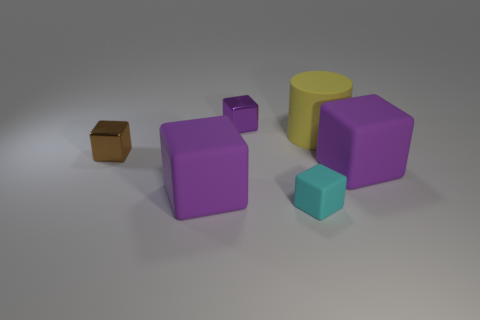What is the material of the large object that is to the left of the tiny matte thing in front of the rubber cylinder?
Give a very brief answer. Rubber. Is the number of tiny purple blocks that are in front of the big yellow rubber thing less than the number of small brown shiny balls?
Provide a short and direct response. No. There is a purple metallic object on the right side of the tiny brown shiny block; what shape is it?
Make the answer very short. Cube. There is a cyan block; does it have the same size as the cube to the right of the rubber cylinder?
Offer a terse response. No. Is there a green sphere that has the same material as the large yellow cylinder?
Offer a very short reply. No. What number of cylinders are either big purple objects or tiny cyan matte things?
Provide a short and direct response. 0. There is a tiny object behind the small brown metal object; are there any big purple rubber cubes on the left side of it?
Make the answer very short. Yes. Is the number of big brown shiny balls less than the number of small brown objects?
Your answer should be compact. Yes. What number of purple shiny things have the same shape as the cyan matte thing?
Your response must be concise. 1. How many cyan things are either rubber things or large cylinders?
Your answer should be compact. 1. 